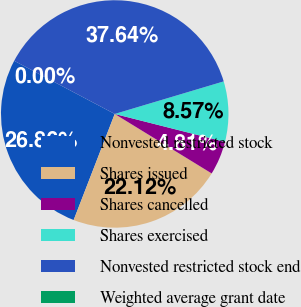Convert chart to OTSL. <chart><loc_0><loc_0><loc_500><loc_500><pie_chart><fcel>Nonvested restricted stock<fcel>Shares issued<fcel>Shares cancelled<fcel>Shares exercised<fcel>Nonvested restricted stock end<fcel>Weighted average grant date<nl><fcel>26.86%<fcel>22.12%<fcel>4.81%<fcel>8.57%<fcel>37.64%<fcel>0.0%<nl></chart> 